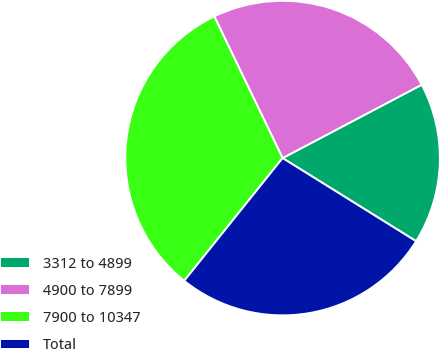Convert chart to OTSL. <chart><loc_0><loc_0><loc_500><loc_500><pie_chart><fcel>3312 to 4899<fcel>4900 to 7899<fcel>7900 to 10347<fcel>Total<nl><fcel>16.59%<fcel>24.43%<fcel>32.1%<fcel>26.89%<nl></chart> 